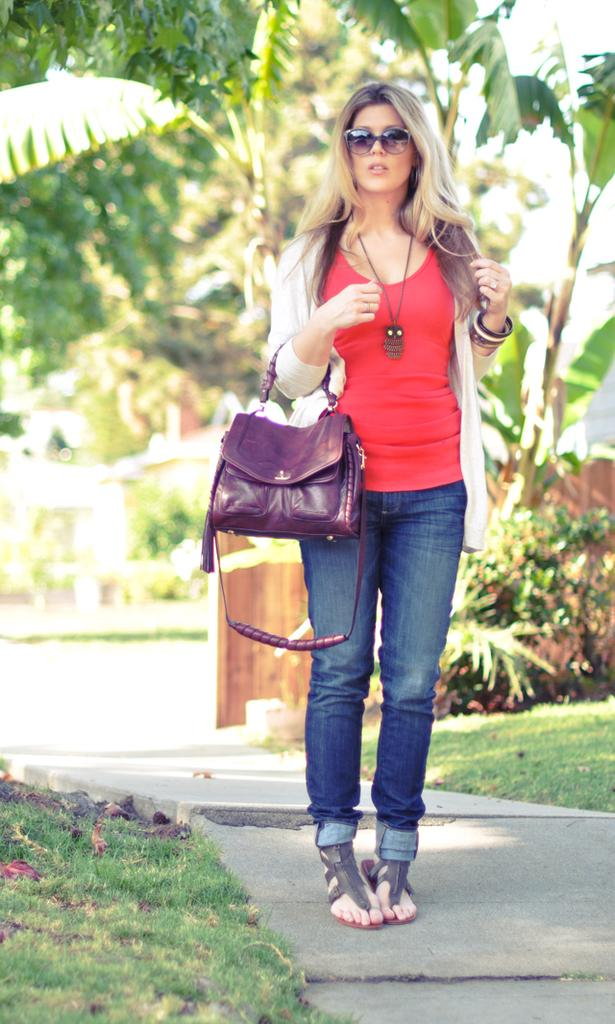Who is present in the image? There is a woman in the image. What is the woman wearing? The woman is wearing a red t-shirt. What is the woman holding in the image? The woman is holding a purple handbag. Where is the woman standing? The woman is standing on a road. What can be seen in the background of the image? There are trees in the background of the image. What type of agreement did the woman make with the tramp in the image? There is no tramp present in the image, and therefore no agreement can be discussed. 